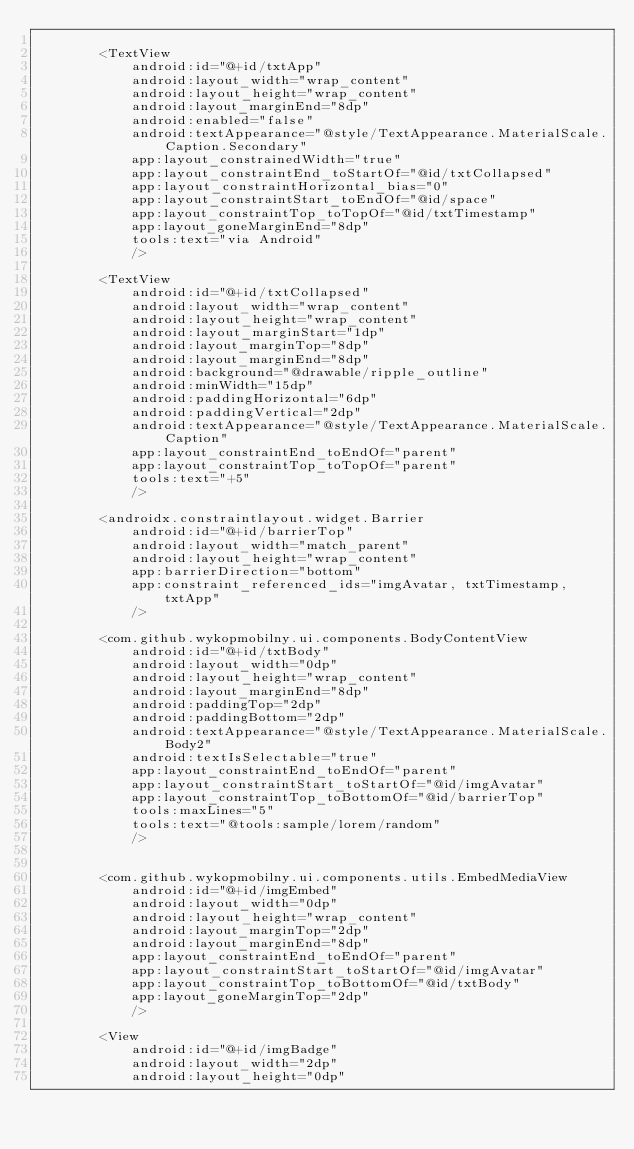Convert code to text. <code><loc_0><loc_0><loc_500><loc_500><_XML_>
        <TextView
            android:id="@+id/txtApp"
            android:layout_width="wrap_content"
            android:layout_height="wrap_content"
            android:layout_marginEnd="8dp"
            android:enabled="false"
            android:textAppearance="@style/TextAppearance.MaterialScale.Caption.Secondary"
            app:layout_constrainedWidth="true"
            app:layout_constraintEnd_toStartOf="@id/txtCollapsed"
            app:layout_constraintHorizontal_bias="0"
            app:layout_constraintStart_toEndOf="@id/space"
            app:layout_constraintTop_toTopOf="@id/txtTimestamp"
            app:layout_goneMarginEnd="8dp"
            tools:text="via Android"
            />

        <TextView
            android:id="@+id/txtCollapsed"
            android:layout_width="wrap_content"
            android:layout_height="wrap_content"
            android:layout_marginStart="1dp"
            android:layout_marginTop="8dp"
            android:layout_marginEnd="8dp"
            android:background="@drawable/ripple_outline"
            android:minWidth="15dp"
            android:paddingHorizontal="6dp"
            android:paddingVertical="2dp"
            android:textAppearance="@style/TextAppearance.MaterialScale.Caption"
            app:layout_constraintEnd_toEndOf="parent"
            app:layout_constraintTop_toTopOf="parent"
            tools:text="+5"
            />

        <androidx.constraintlayout.widget.Barrier
            android:id="@+id/barrierTop"
            android:layout_width="match_parent"
            android:layout_height="wrap_content"
            app:barrierDirection="bottom"
            app:constraint_referenced_ids="imgAvatar, txtTimestamp, txtApp"
            />

        <com.github.wykopmobilny.ui.components.BodyContentView
            android:id="@+id/txtBody"
            android:layout_width="0dp"
            android:layout_height="wrap_content"
            android:layout_marginEnd="8dp"
            android:paddingTop="2dp"
            android:paddingBottom="2dp"
            android:textAppearance="@style/TextAppearance.MaterialScale.Body2"
            android:textIsSelectable="true"
            app:layout_constraintEnd_toEndOf="parent"
            app:layout_constraintStart_toStartOf="@id/imgAvatar"
            app:layout_constraintTop_toBottomOf="@id/barrierTop"
            tools:maxLines="5"
            tools:text="@tools:sample/lorem/random"
            />


        <com.github.wykopmobilny.ui.components.utils.EmbedMediaView
            android:id="@+id/imgEmbed"
            android:layout_width="0dp"
            android:layout_height="wrap_content"
            android:layout_marginTop="2dp"
            android:layout_marginEnd="8dp"
            app:layout_constraintEnd_toEndOf="parent"
            app:layout_constraintStart_toStartOf="@id/imgAvatar"
            app:layout_constraintTop_toBottomOf="@id/txtBody"
            app:layout_goneMarginTop="2dp"
            />

        <View
            android:id="@+id/imgBadge"
            android:layout_width="2dp"
            android:layout_height="0dp"</code> 